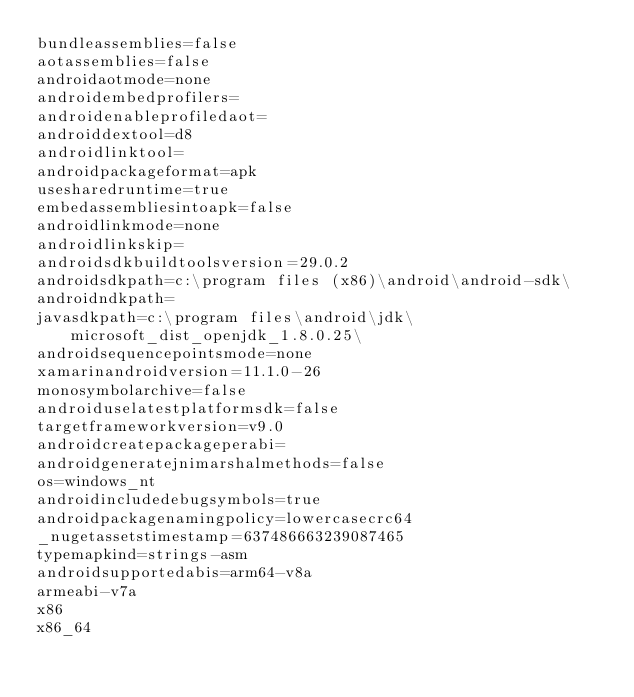<code> <loc_0><loc_0><loc_500><loc_500><_XML_>bundleassemblies=false
aotassemblies=false
androidaotmode=none
androidembedprofilers=
androidenableprofiledaot=
androiddextool=d8
androidlinktool=
androidpackageformat=apk
usesharedruntime=true
embedassembliesintoapk=false
androidlinkmode=none
androidlinkskip=
androidsdkbuildtoolsversion=29.0.2
androidsdkpath=c:\program files (x86)\android\android-sdk\
androidndkpath=
javasdkpath=c:\program files\android\jdk\microsoft_dist_openjdk_1.8.0.25\
androidsequencepointsmode=none
xamarinandroidversion=11.1.0-26
monosymbolarchive=false
androiduselatestplatformsdk=false
targetframeworkversion=v9.0
androidcreatepackageperabi=
androidgeneratejnimarshalmethods=false
os=windows_nt
androidincludedebugsymbols=true
androidpackagenamingpolicy=lowercasecrc64
_nugetassetstimestamp=637486663239087465
typemapkind=strings-asm
androidsupportedabis=arm64-v8a
armeabi-v7a
x86
x86_64
</code> 